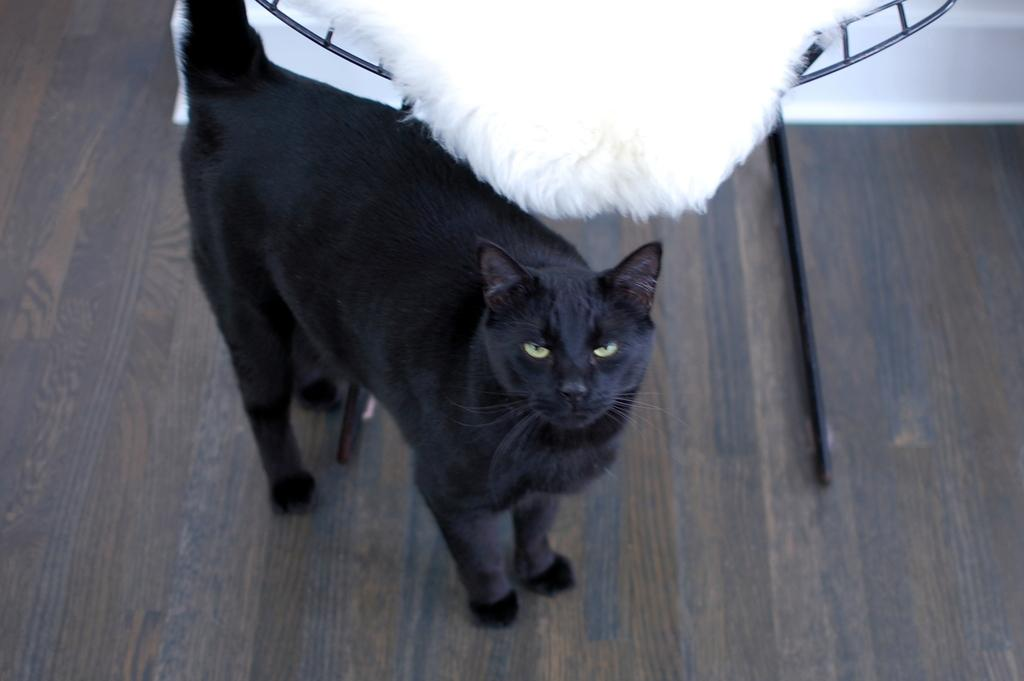What type of animal is in the image? There is a black cat in the image. What is the surface beneath the cat? The cat is on a wooden floor. What can be seen in the background of the image? There is a chair in the background of the image. What is on the chair? There is a white pillow on the chair. How does the cat contribute to pollution in the image? The cat does not contribute to pollution in the image; there is no indication of pollution in the image. 